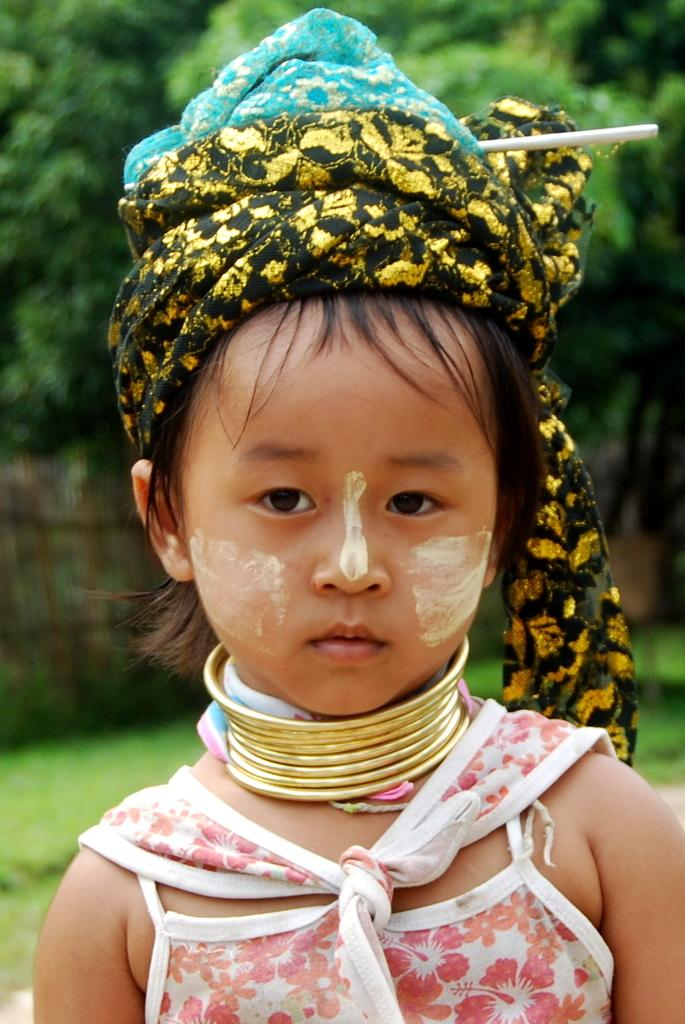Who is the main subject in the image? There is a girl standing in the image. What can be seen in the background of the image? There are trees and a grassland in the background of the image. What type of furniture can be seen in the image? There is no furniture present in the image. Can you describe the street where the girl is standing in the image? There is no street visible in the image; it appears to be set in a grassland with trees in the background. 